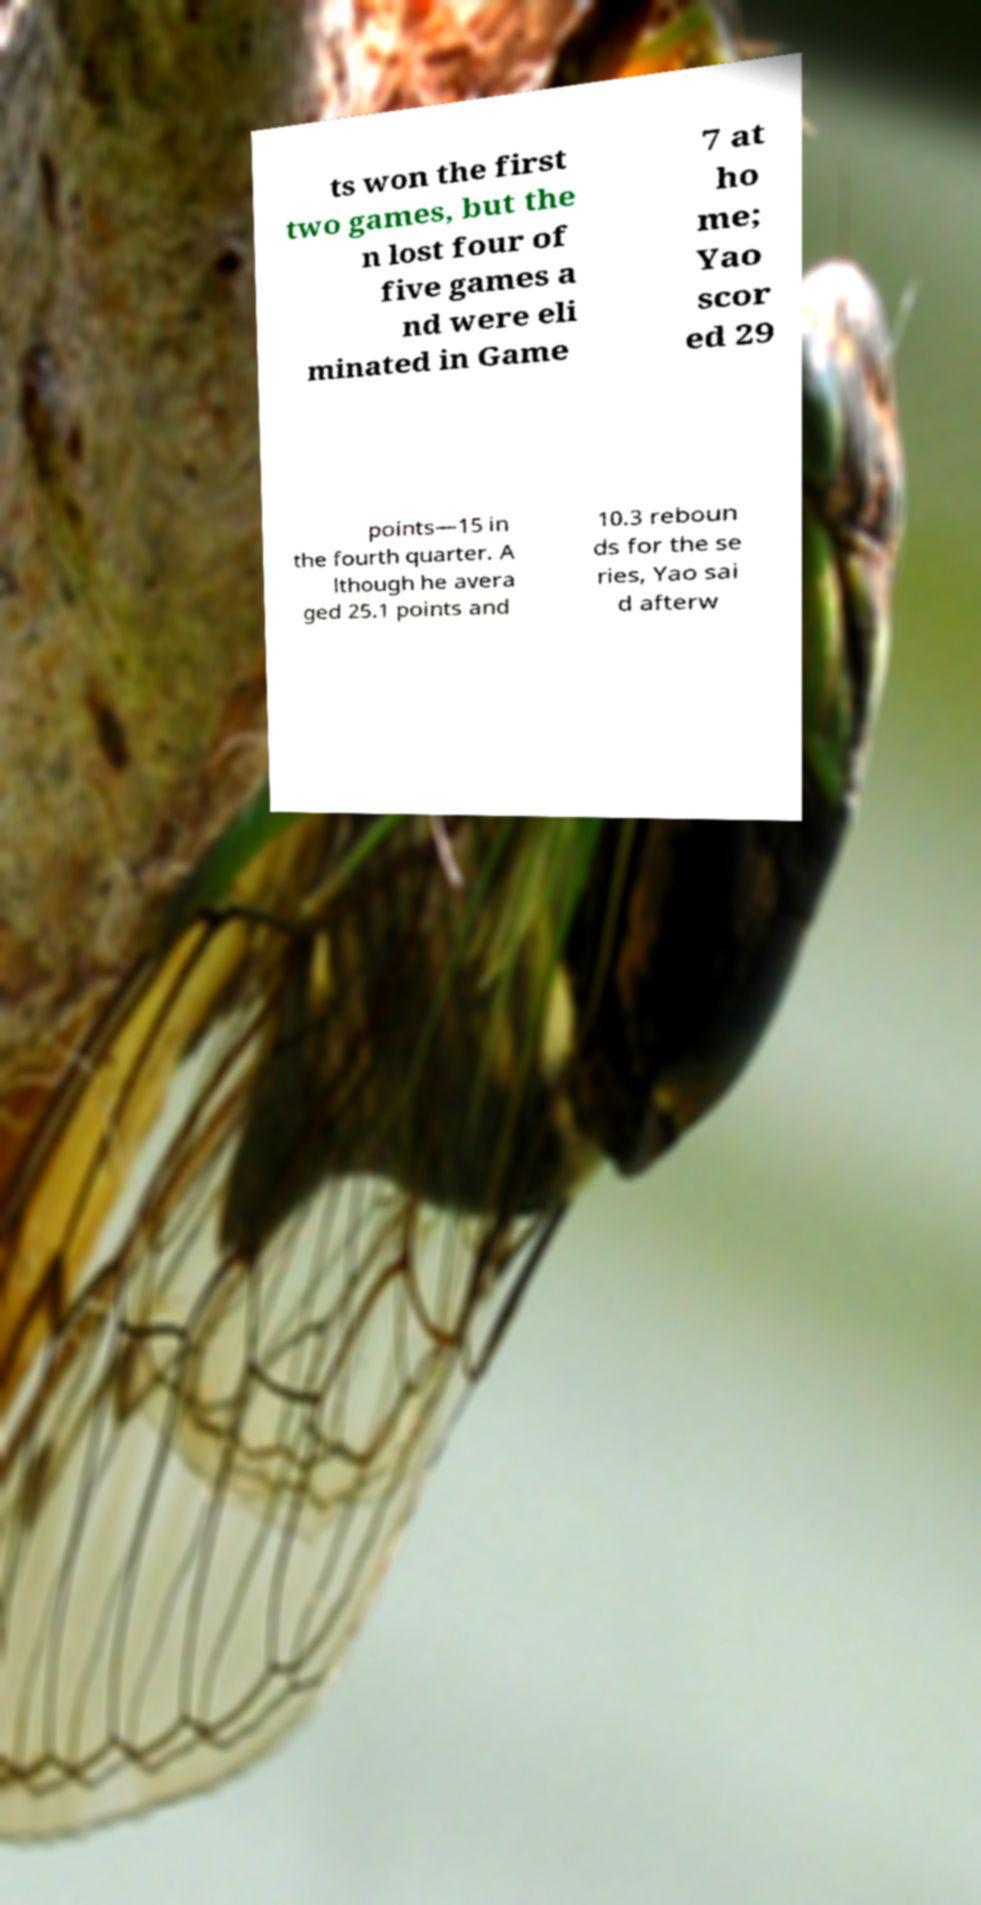What messages or text are displayed in this image? I need them in a readable, typed format. ts won the first two games, but the n lost four of five games a nd were eli minated in Game 7 at ho me; Yao scor ed 29 points—15 in the fourth quarter. A lthough he avera ged 25.1 points and 10.3 reboun ds for the se ries, Yao sai d afterw 